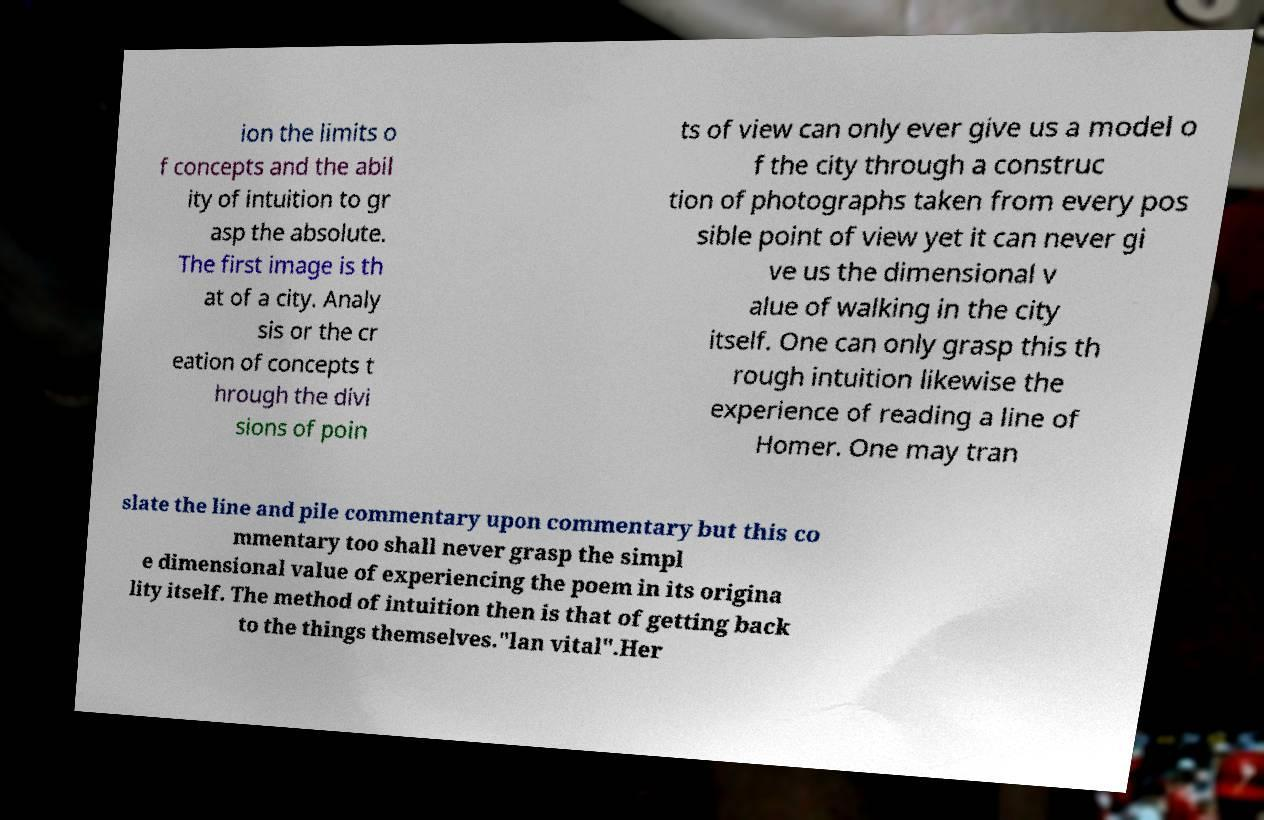What messages or text are displayed in this image? I need them in a readable, typed format. ion the limits o f concepts and the abil ity of intuition to gr asp the absolute. The first image is th at of a city. Analy sis or the cr eation of concepts t hrough the divi sions of poin ts of view can only ever give us a model o f the city through a construc tion of photographs taken from every pos sible point of view yet it can never gi ve us the dimensional v alue of walking in the city itself. One can only grasp this th rough intuition likewise the experience of reading a line of Homer. One may tran slate the line and pile commentary upon commentary but this co mmentary too shall never grasp the simpl e dimensional value of experiencing the poem in its origina lity itself. The method of intuition then is that of getting back to the things themselves."lan vital".Her 